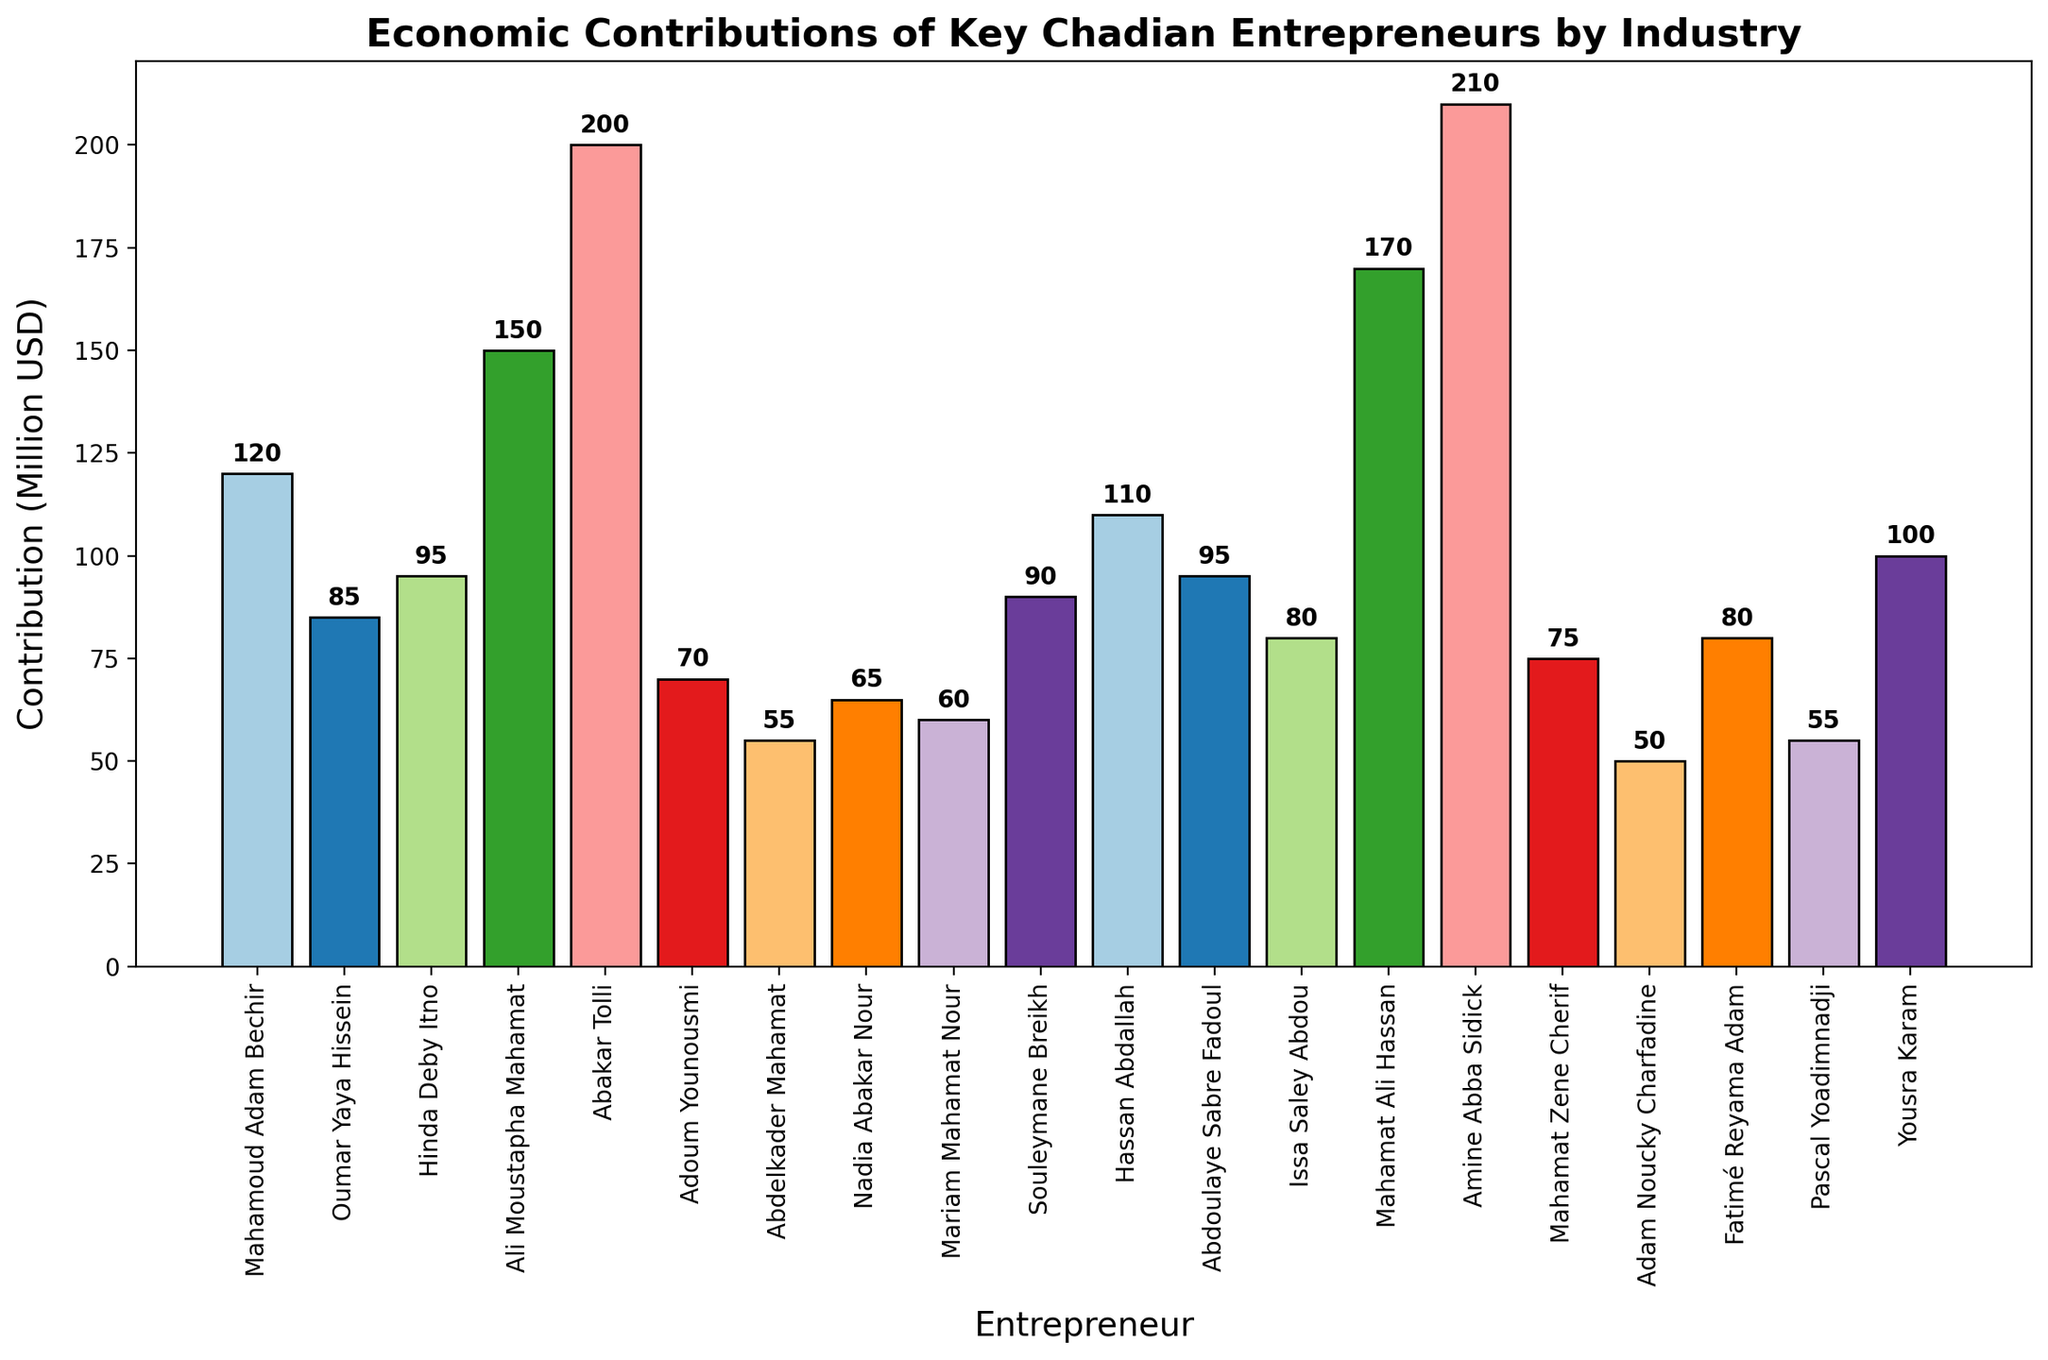what is the total economic contribution of entrepreneurs in the agriculture industry? There are two entrepreneurs in the agriculture industry: Mahamoud Adam Bechir with a contribution of 120 million USD and Hassan Abdallah with a contribution of 110 million USD. Adding their contributions together gives 120 + 110 = 230 million USD.
Answer: 230 million USD Who contributed more in the financial services industry, Mahamat Ali Hassan or Ali Moustapha Mahamat? Mahamat Ali Hassan contributed 170 million USD, while Ali Moustapha Mahamat contributed 150 million USD. By comparing these values, Mahamat Ali Hassan contributed more.
Answer: Mahamat Ali Hassan Among the industries listed, which entrepreneur has the highest economic contribution, and what is the amount? The entrepreneur with the highest economic contribution is Amine Abba Sidick in the energy industry with a contribution of 210 million USD.
Answer: Amine Abba Sidick, 210 million USD Which industry has the least economic contribution, and who are the entrepreneurs in that industry? By observing all contributions, the tourism industry has the least combined economic contribution: Abdelkader Mahamat with 55 million USD and Adam Noucky Charfadine with 50 million USD.
Answer: Tourism, Abdelkader Mahamat and Adam Noucky Charfadine What is the average contribution of the entrepreneurs in the technology industry? There are two entrepreneurs in the technology industry: Souleymane Breikh with a contribution of 90 million USD and Yousra Karam with a contribution of 100 million USD. The average is calculated as (90 + 100) / 2 = 95 million USD.
Answer: 95 million USD Which entrepreneur in the retail industry has a higher contribution, and by how much? In the retail industry, Mahamat Zene Cherif contributed 75 million USD, while Adoum Younousmi contributed 70 million USD. Mahamat Zene Cherif contributed more by 75 - 70 = 5 million USD.
Answer: Mahamat Zene Cherif, 5 million USD What is the combined economic contribution of entrepreneurs in health services? There are two entrepreneurs in health services: Nadia Abakar Nour with 65 million USD and Fatimé Reyama Adam with 80 million USD. Adding these gives 65 + 80 = 145 million USD.
Answer: 145 million USD What is the difference in contribution between the top entrepreneur in the construction industry and the top entrepreneur in the telecommunications industry? The top contributor in the construction industry is Abdoulaye Sabre Fadoul with 95 million USD, and in telecommunications, it is Hinda Deby Itno with 95 million USD. The difference is 95 - 95 = 0 million USD.
Answer: 0 million USD 